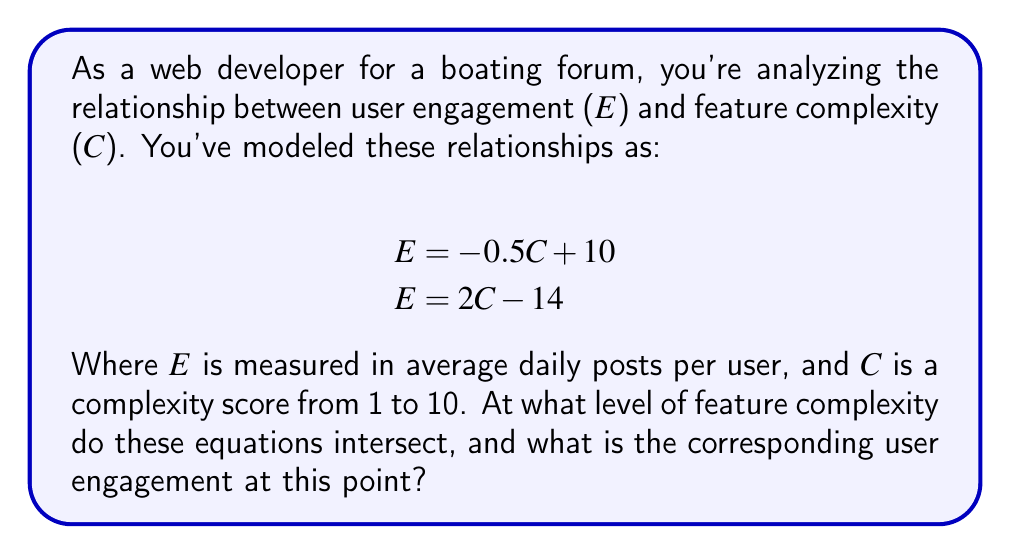Solve this math problem. To solve this system of equations, we need to find the point where both equations are true simultaneously. This is the intersection point.

1. Set the two equations equal to each other:
   $$-0.5C + 10 = 2C - 14$$

2. Solve for C:
   $$-0.5C + 10 = 2C - 14$$
   $$24 = 2.5C$$
   $$C = \frac{24}{2.5} = 9.6$$

3. Now that we know C, we can substitute it into either of the original equations to find E. Let's use the first equation:
   $$E = -0.5C + 10$$
   $$E = -0.5(9.6) + 10$$
   $$E = -4.8 + 10 = 5.2$$

4. Check: We can verify this solution by plugging the values into the second equation:
   $$E = 2C - 14$$
   $$5.2 = 2(9.6) - 14$$
   $$5.2 = 19.2 - 14 = 5.2$$

This confirms our solution is correct.

Interpretation: The equations intersect when the feature complexity score is 9.6, corresponding to a user engagement of 5.2 average daily posts per user.
Answer: The equations intersect at the point $(C, E) = (9.6, 5.2)$, meaning a feature complexity score of 9.6 corresponds to 5.2 average daily posts per user. 